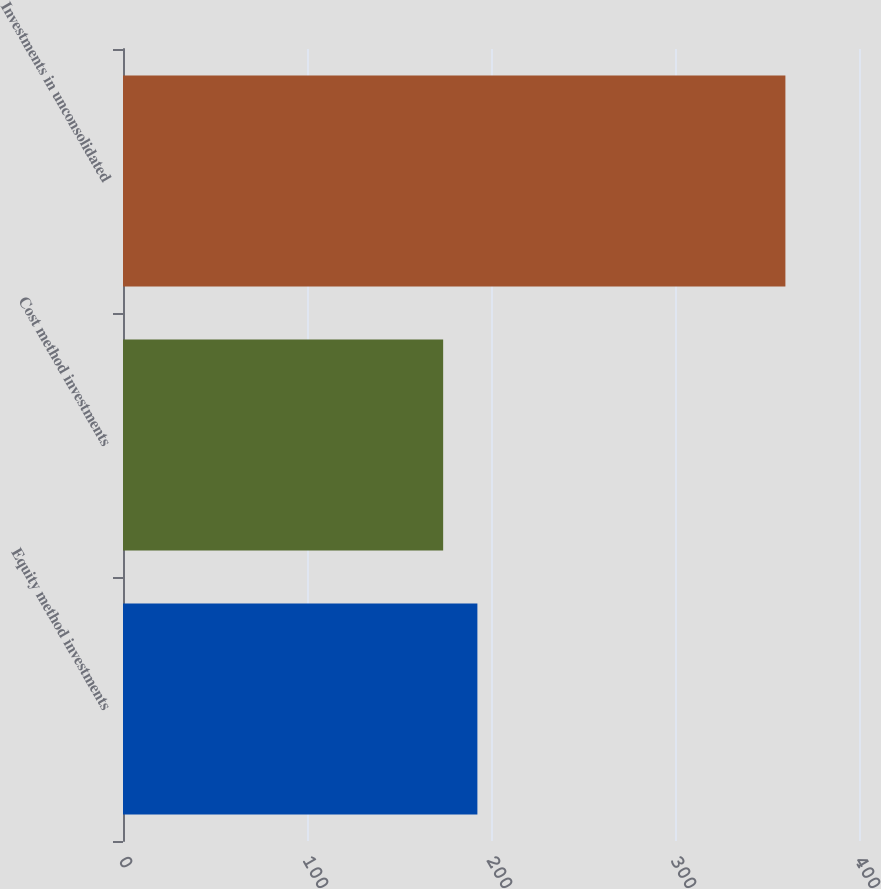Convert chart. <chart><loc_0><loc_0><loc_500><loc_500><bar_chart><fcel>Equity method investments<fcel>Cost method investments<fcel>Investments in unconsolidated<nl><fcel>192.6<fcel>174<fcel>360<nl></chart> 